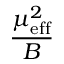<formula> <loc_0><loc_0><loc_500><loc_500>\frac { \mu _ { e f f } ^ { 2 } } { B }</formula> 